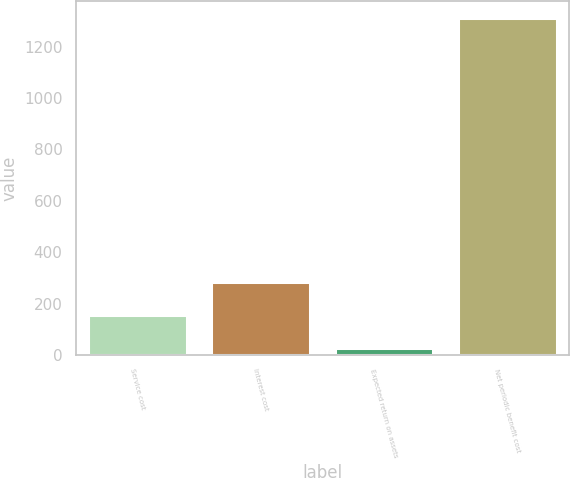Convert chart. <chart><loc_0><loc_0><loc_500><loc_500><bar_chart><fcel>Service cost<fcel>Interest cost<fcel>Expected return on assets<fcel>Net periodic benefit cost<nl><fcel>153.7<fcel>282.4<fcel>25<fcel>1312<nl></chart> 